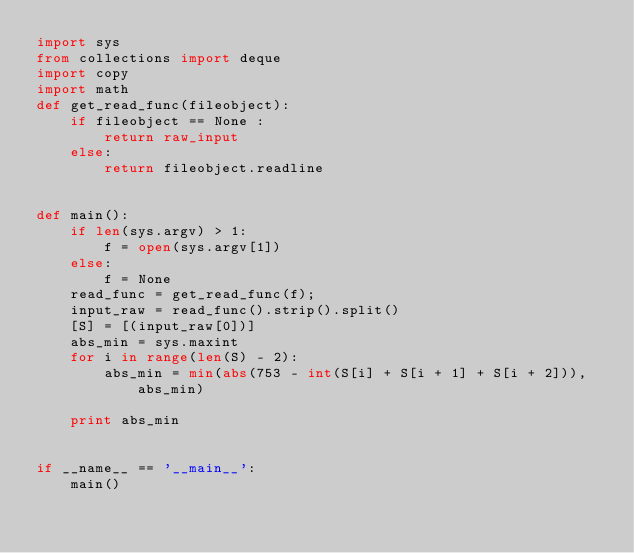Convert code to text. <code><loc_0><loc_0><loc_500><loc_500><_Python_>import sys
from collections import deque
import copy
import math
def get_read_func(fileobject):
    if fileobject == None :
        return raw_input
    else:
        return fileobject.readline


def main():
    if len(sys.argv) > 1:
        f = open(sys.argv[1])
    else:
        f = None
    read_func = get_read_func(f);
    input_raw = read_func().strip().split()
    [S] = [(input_raw[0])]
    abs_min = sys.maxint
    for i in range(len(S) - 2):
        abs_min = min(abs(753 - int(S[i] + S[i + 1] + S[i + 2])), abs_min)

    print abs_min


if __name__ == '__main__':
    main()</code> 